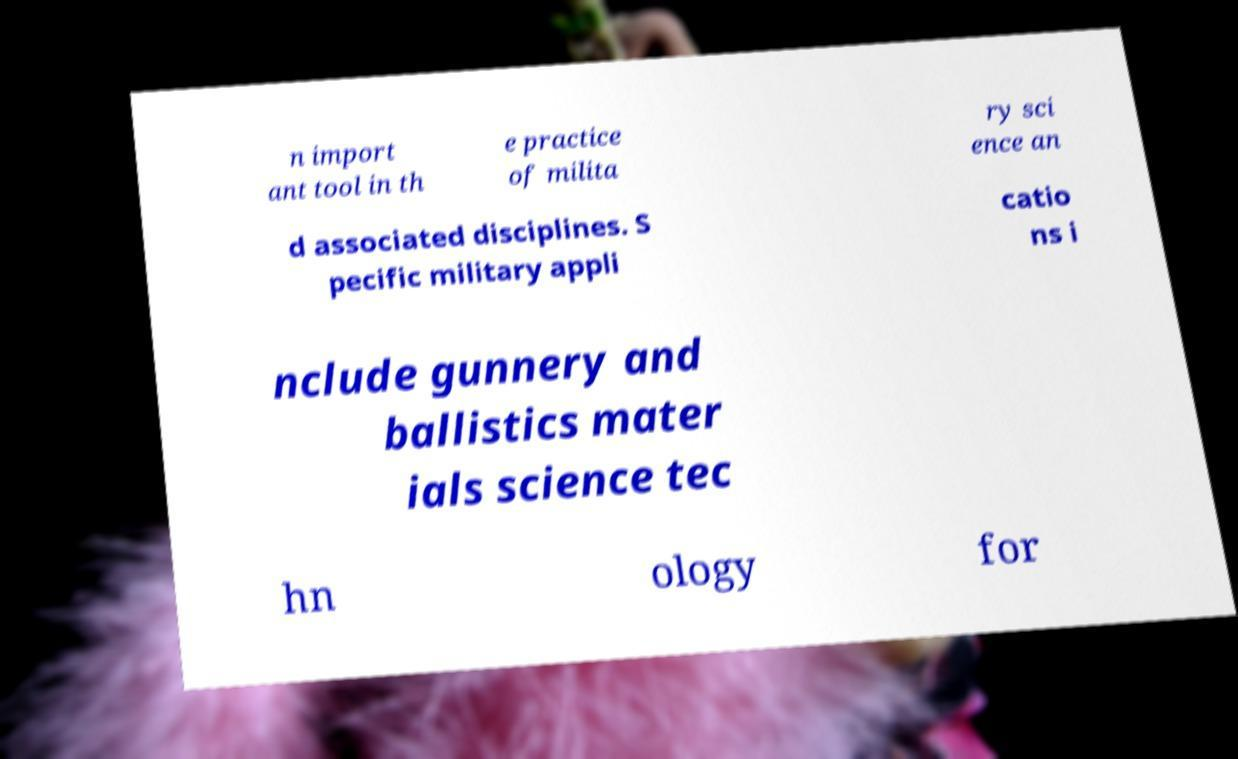For documentation purposes, I need the text within this image transcribed. Could you provide that? n import ant tool in th e practice of milita ry sci ence an d associated disciplines. S pecific military appli catio ns i nclude gunnery and ballistics mater ials science tec hn ology for 